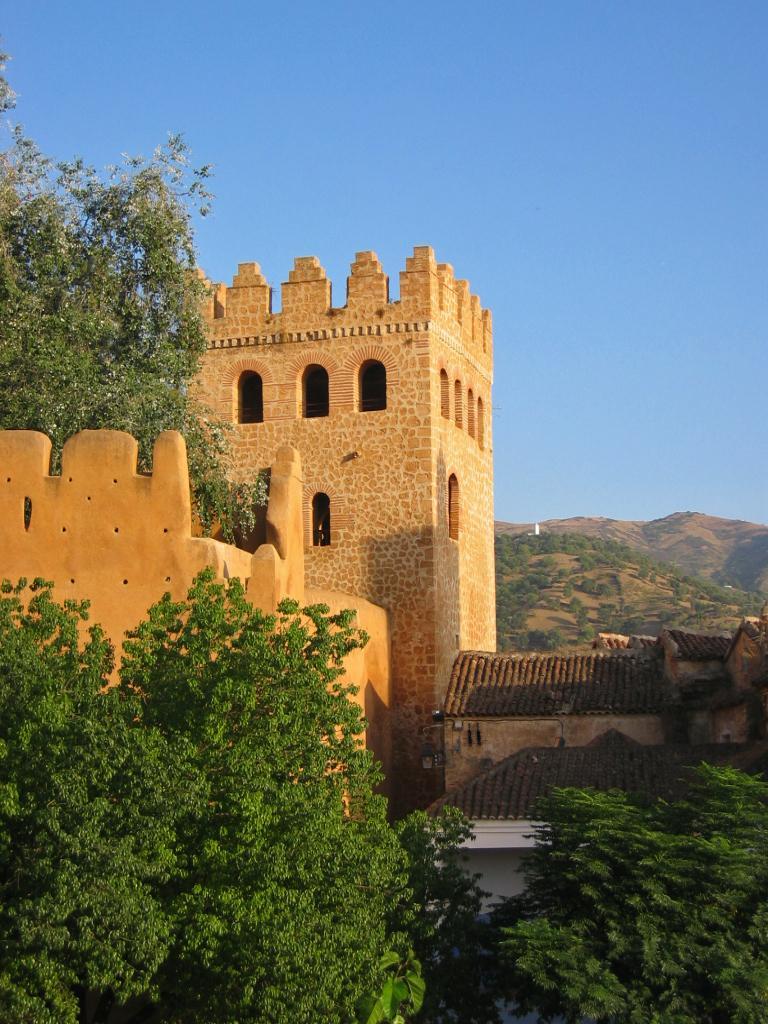Can you describe this image briefly? In this picture we can see buildings, trees, mountains and in the background we can see the sky. 